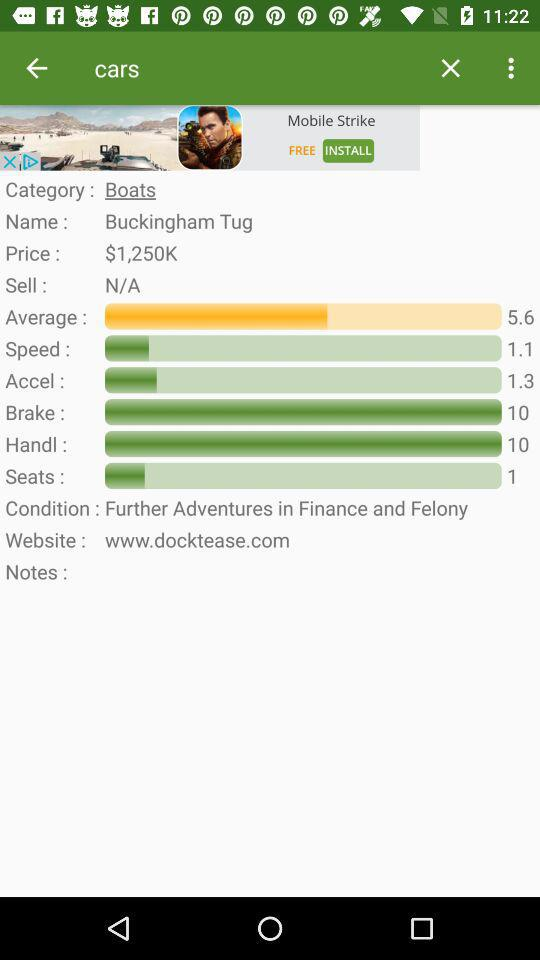Which items are available in the sell option? The items available are N/A. 